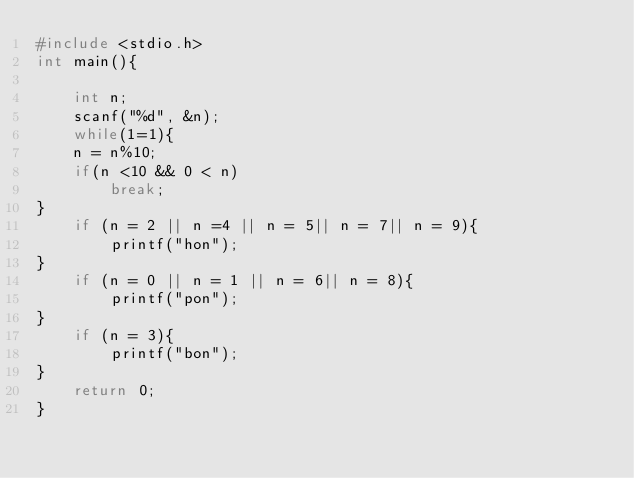<code> <loc_0><loc_0><loc_500><loc_500><_C_>#include <stdio.h>
int main(){

    int n;
    scanf("%d", &n);
    while(1=1){
    n = n%10;
    if(n <10 && 0 < n)
        break;
}
    if (n = 2 || n =4 || n = 5|| n = 7|| n = 9){
        printf("hon");
}
    if (n = 0 || n = 1 || n = 6|| n = 8){
        printf("pon");
}
    if (n = 3){
        printf("bon");
}
    return 0;
}</code> 